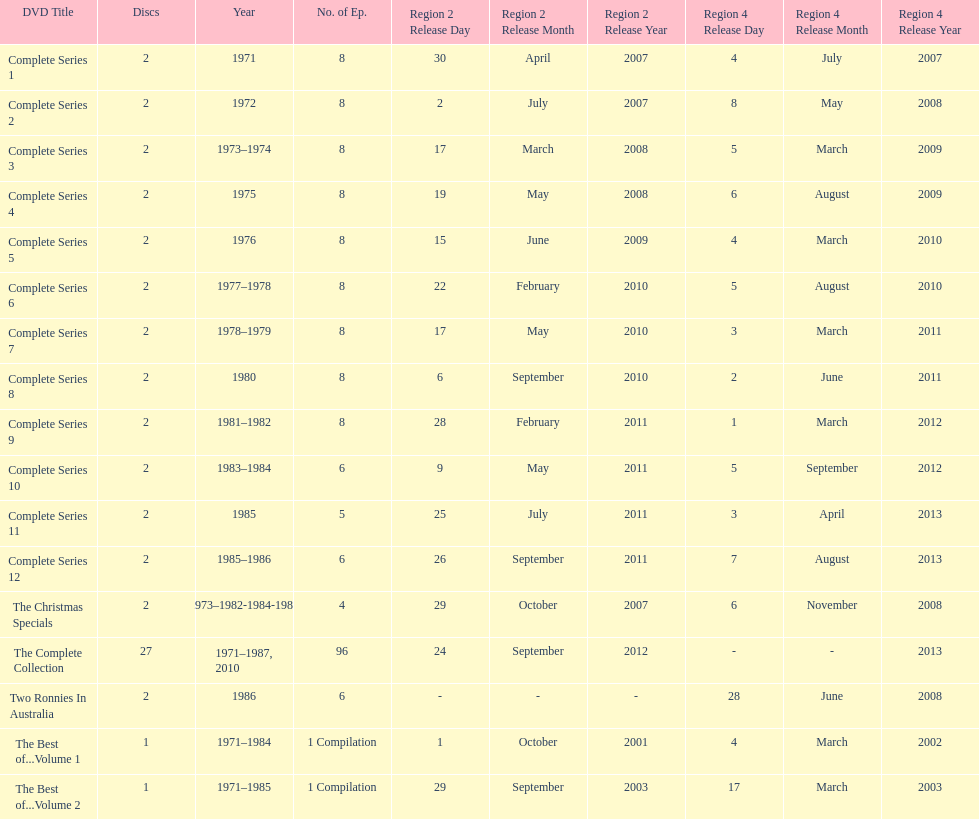The television show "the two ronnies" ran for a total of how many seasons? 12. 